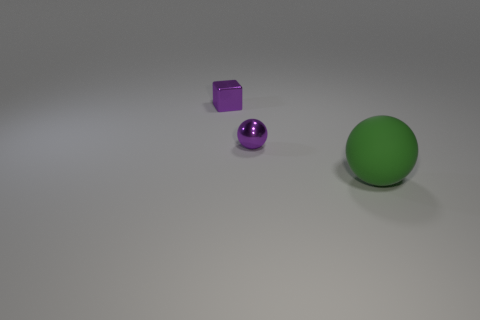There is a metallic thing on the left side of the sphere behind the large green ball; what size is it?
Your answer should be compact. Small. Is the number of small metal spheres right of the tiny ball the same as the number of tiny purple metal spheres behind the purple metal block?
Your answer should be compact. Yes. There is a ball behind the matte object; is there a green matte sphere right of it?
Ensure brevity in your answer.  Yes. What number of big balls are on the left side of the object that is right of the metallic object in front of the purple shiny block?
Keep it short and to the point. 0. Are there fewer cyan metal cylinders than tiny metal objects?
Make the answer very short. Yes. Is the shape of the object right of the purple metallic sphere the same as the small purple shiny thing that is in front of the tiny metallic block?
Provide a short and direct response. Yes. What color is the small ball?
Offer a very short reply. Purple. How many metal objects are either tiny cubes or purple balls?
Offer a very short reply. 2. There is another small metallic object that is the same shape as the green object; what color is it?
Keep it short and to the point. Purple. Is there a small green metallic thing?
Provide a succinct answer. No. 